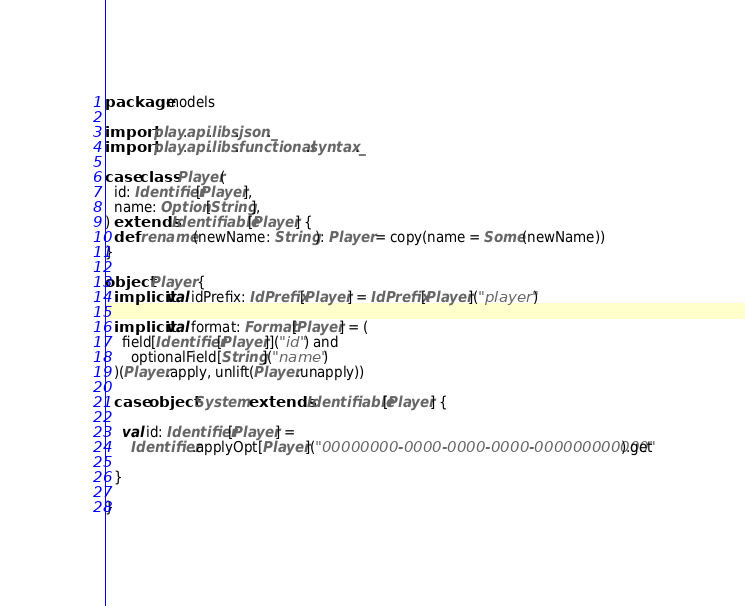Convert code to text. <code><loc_0><loc_0><loc_500><loc_500><_Scala_>package models

import play.api.libs.json._
import play.api.libs.functional.syntax._

case class Player(
  id: Identifier[Player],
  name: Option[String],
) extends Identifiable[Player] {
  def rename(newName: String): Player = copy(name = Some(newName))
}

object Player {
  implicit val idPrefix: IdPrefix[Player] = IdPrefix[Player]("player")

  implicit val format: Format[Player] = (
    field[Identifier[Player]]("id") and
      optionalField[String]("name")
  )(Player.apply, unlift(Player.unapply))

  case object System extends Identifiable[Player] {

    val id: Identifier[Player] =
      Identifier.applyOpt[Player]("00000000-0000-0000-0000-000000000000").get

  }

}
</code> 